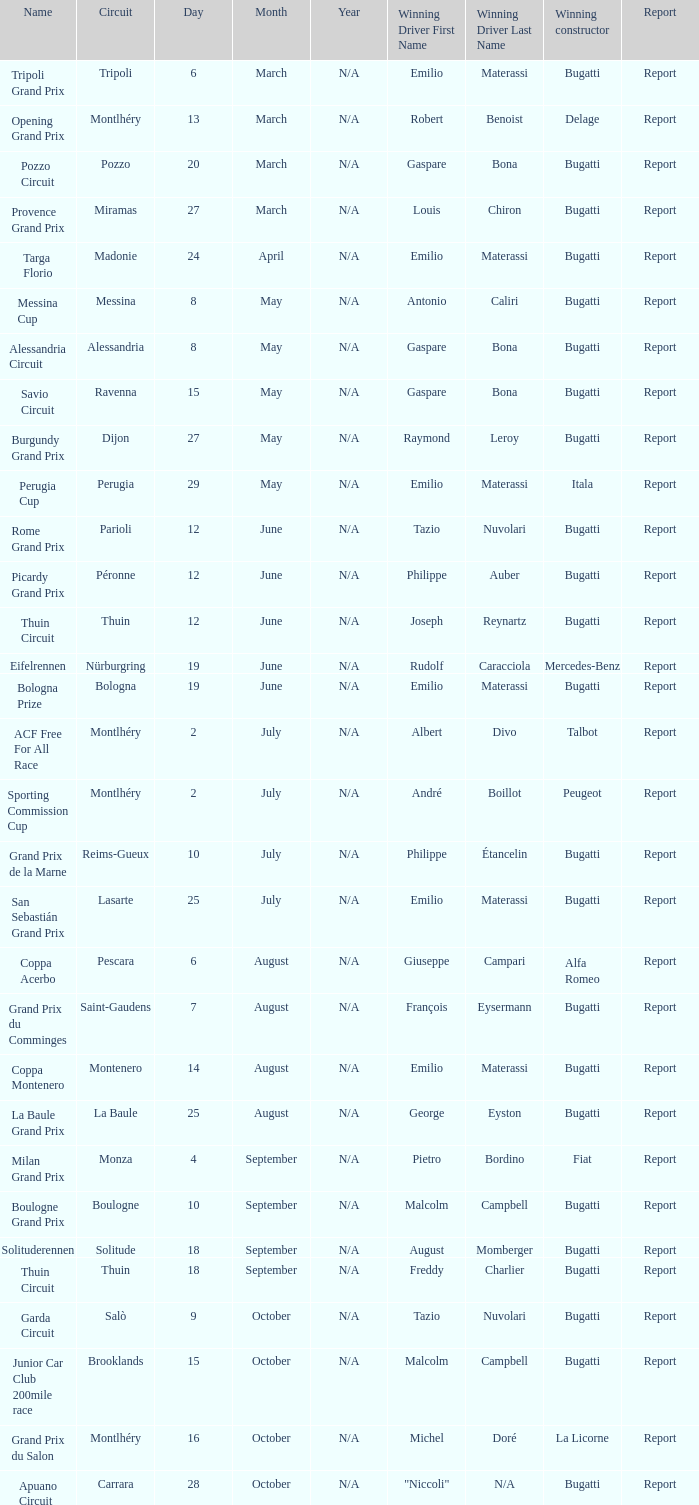In which circuit did françois eysermann achieve victory? Saint-Gaudens. 